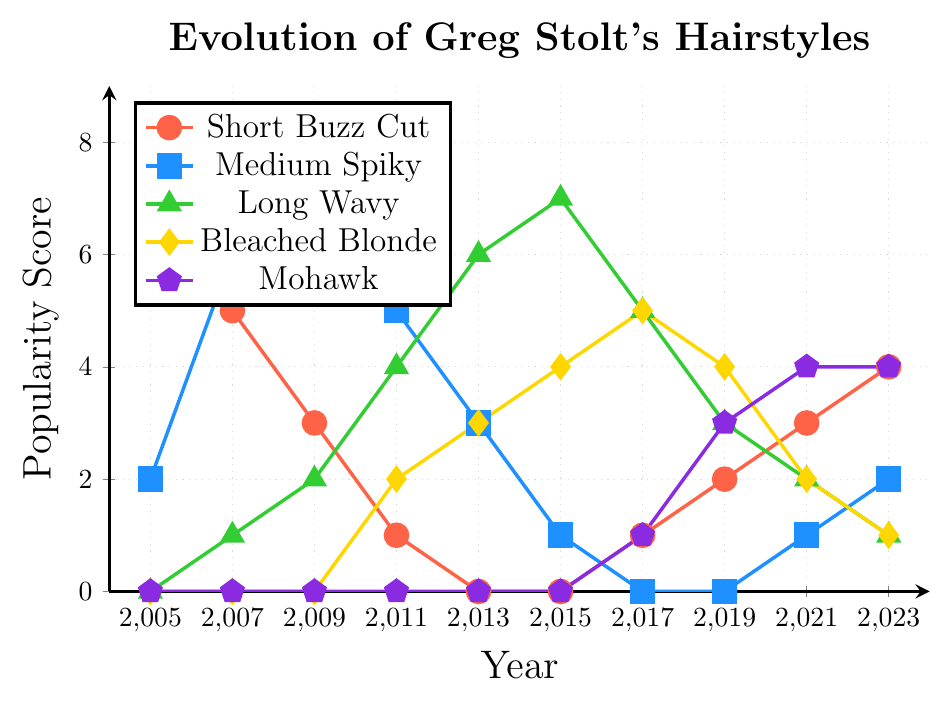Which hairstyle had the highest popularity score in 2005? Looking at the line chart, the "Short Buzz Cut" peaks at 8 in 2005, which is the highest score for that year.
Answer: Short Buzz Cut How did the popularity of the "Medium Spiky" hairstyle change from 2009 to 2013? In 2009, "Medium Spiky" had a score of 7. By 2013, this score dropped to 3. The change is calculated as 3 - 7 = -4, indicating a decrease of 4 points.
Answer: Decreased by 4 points What is the difference in popularity score between "Long Wavy" and "Bleached Blonde" hairstyles in 2011? In 2011, the score for "Long Wavy" is 4, and for "Bleached Blonde," it is 2. The difference is 4 - 2 = 2.
Answer: 2 In which year did the "Mohawk" hairstyle become as popular as "Bleached Blonde"? Checking the graph, both "Mohawk" and "Bleached Blonde" have the same score of 4 in 2021.
Answer: 2021 What was the trend for the "Short Buzz Cut" from 2005 to 2013? The "Short Buzz Cut" starts with 8 in 2005, then gradually declines to 0 by 2013. This pattern shows a decreasing trend.
Answer: Decreasing Which year had the most variety in terms of the number of different hairstyles with non-zero popularity scores? By inspecting the chart for each year, 2011 is the year where all five hairstyles have non-zero scores.
Answer: 2011 What is the average popularity score of the "Long Wavy" hairstyle across all the years? The scores are 0, 1, 2, 4, 6, 7, 5, 3, 2, and 1. Adding them up gives 31, and dividing by 10 years results in an average score of 3.1.
Answer: 3.1 Compare the popularity changes of "Short Buzz Cut" and "Mohawk" between 2017 and 2023. Which had a greater increase? From 2017 to 2023, "Short Buzz Cut" changes from 1 to 4, an increase of 3; "Mohawk" changes from 1 to 4, an increase of 3. Both had the same increase of 3.
Answer: Same increase of 3 Between 2005 and 2023, in which year did the "Medium Spiky" hairstyle reach its peak popularity? Observing the chart, the "Medium Spiky" hairstyle peaks at a score of 7 in 2009.
Answer: 2009 